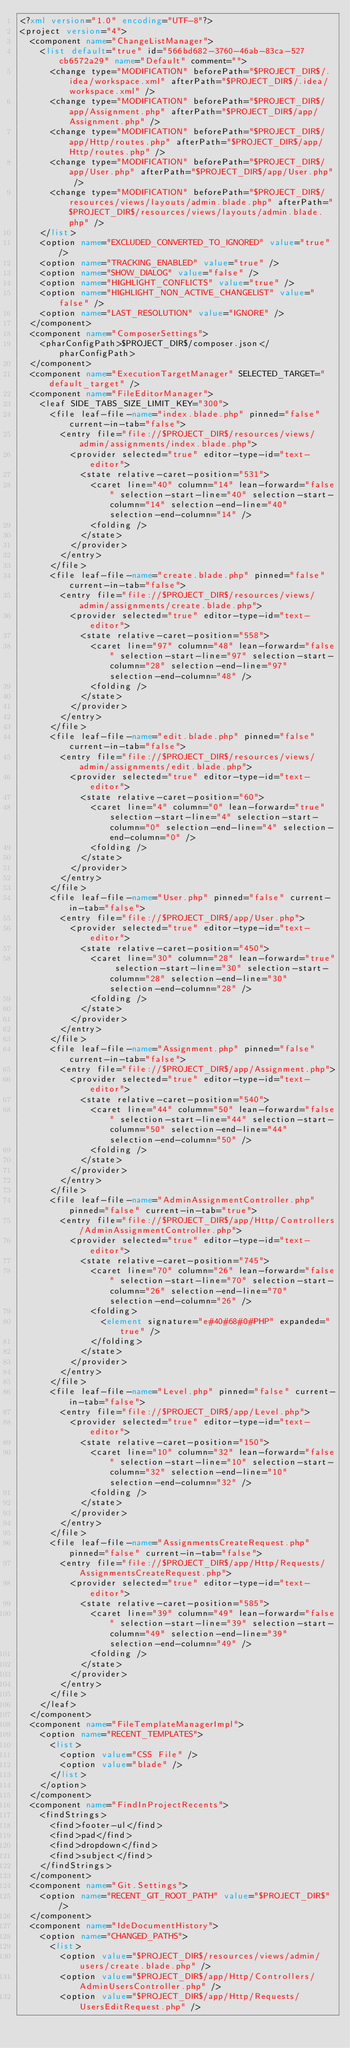Convert code to text. <code><loc_0><loc_0><loc_500><loc_500><_XML_><?xml version="1.0" encoding="UTF-8"?>
<project version="4">
  <component name="ChangeListManager">
    <list default="true" id="566bd682-3760-46ab-83ca-527cb6572a29" name="Default" comment="">
      <change type="MODIFICATION" beforePath="$PROJECT_DIR$/.idea/workspace.xml" afterPath="$PROJECT_DIR$/.idea/workspace.xml" />
      <change type="MODIFICATION" beforePath="$PROJECT_DIR$/app/Assignment.php" afterPath="$PROJECT_DIR$/app/Assignment.php" />
      <change type="MODIFICATION" beforePath="$PROJECT_DIR$/app/Http/routes.php" afterPath="$PROJECT_DIR$/app/Http/routes.php" />
      <change type="MODIFICATION" beforePath="$PROJECT_DIR$/app/User.php" afterPath="$PROJECT_DIR$/app/User.php" />
      <change type="MODIFICATION" beforePath="$PROJECT_DIR$/resources/views/layouts/admin.blade.php" afterPath="$PROJECT_DIR$/resources/views/layouts/admin.blade.php" />
    </list>
    <option name="EXCLUDED_CONVERTED_TO_IGNORED" value="true" />
    <option name="TRACKING_ENABLED" value="true" />
    <option name="SHOW_DIALOG" value="false" />
    <option name="HIGHLIGHT_CONFLICTS" value="true" />
    <option name="HIGHLIGHT_NON_ACTIVE_CHANGELIST" value="false" />
    <option name="LAST_RESOLUTION" value="IGNORE" />
  </component>
  <component name="ComposerSettings">
    <pharConfigPath>$PROJECT_DIR$/composer.json</pharConfigPath>
  </component>
  <component name="ExecutionTargetManager" SELECTED_TARGET="default_target" />
  <component name="FileEditorManager">
    <leaf SIDE_TABS_SIZE_LIMIT_KEY="300">
      <file leaf-file-name="index.blade.php" pinned="false" current-in-tab="false">
        <entry file="file://$PROJECT_DIR$/resources/views/admin/assignments/index.blade.php">
          <provider selected="true" editor-type-id="text-editor">
            <state relative-caret-position="531">
              <caret line="40" column="14" lean-forward="false" selection-start-line="40" selection-start-column="14" selection-end-line="40" selection-end-column="14" />
              <folding />
            </state>
          </provider>
        </entry>
      </file>
      <file leaf-file-name="create.blade.php" pinned="false" current-in-tab="false">
        <entry file="file://$PROJECT_DIR$/resources/views/admin/assignments/create.blade.php">
          <provider selected="true" editor-type-id="text-editor">
            <state relative-caret-position="558">
              <caret line="97" column="48" lean-forward="false" selection-start-line="97" selection-start-column="28" selection-end-line="97" selection-end-column="48" />
              <folding />
            </state>
          </provider>
        </entry>
      </file>
      <file leaf-file-name="edit.blade.php" pinned="false" current-in-tab="false">
        <entry file="file://$PROJECT_DIR$/resources/views/admin/assignments/edit.blade.php">
          <provider selected="true" editor-type-id="text-editor">
            <state relative-caret-position="60">
              <caret line="4" column="0" lean-forward="true" selection-start-line="4" selection-start-column="0" selection-end-line="4" selection-end-column="0" />
              <folding />
            </state>
          </provider>
        </entry>
      </file>
      <file leaf-file-name="User.php" pinned="false" current-in-tab="false">
        <entry file="file://$PROJECT_DIR$/app/User.php">
          <provider selected="true" editor-type-id="text-editor">
            <state relative-caret-position="450">
              <caret line="30" column="28" lean-forward="true" selection-start-line="30" selection-start-column="28" selection-end-line="30" selection-end-column="28" />
              <folding />
            </state>
          </provider>
        </entry>
      </file>
      <file leaf-file-name="Assignment.php" pinned="false" current-in-tab="false">
        <entry file="file://$PROJECT_DIR$/app/Assignment.php">
          <provider selected="true" editor-type-id="text-editor">
            <state relative-caret-position="540">
              <caret line="44" column="50" lean-forward="false" selection-start-line="44" selection-start-column="50" selection-end-line="44" selection-end-column="50" />
              <folding />
            </state>
          </provider>
        </entry>
      </file>
      <file leaf-file-name="AdminAssignmentController.php" pinned="false" current-in-tab="true">
        <entry file="file://$PROJECT_DIR$/app/Http/Controllers/AdminAssignmentController.php">
          <provider selected="true" editor-type-id="text-editor">
            <state relative-caret-position="745">
              <caret line="70" column="26" lean-forward="false" selection-start-line="70" selection-start-column="26" selection-end-line="70" selection-end-column="26" />
              <folding>
                <element signature="e#40#68#0#PHP" expanded="true" />
              </folding>
            </state>
          </provider>
        </entry>
      </file>
      <file leaf-file-name="Level.php" pinned="false" current-in-tab="false">
        <entry file="file://$PROJECT_DIR$/app/Level.php">
          <provider selected="true" editor-type-id="text-editor">
            <state relative-caret-position="150">
              <caret line="10" column="32" lean-forward="false" selection-start-line="10" selection-start-column="32" selection-end-line="10" selection-end-column="32" />
              <folding />
            </state>
          </provider>
        </entry>
      </file>
      <file leaf-file-name="AssignmentsCreateRequest.php" pinned="false" current-in-tab="false">
        <entry file="file://$PROJECT_DIR$/app/Http/Requests/AssignmentsCreateRequest.php">
          <provider selected="true" editor-type-id="text-editor">
            <state relative-caret-position="585">
              <caret line="39" column="49" lean-forward="false" selection-start-line="39" selection-start-column="49" selection-end-line="39" selection-end-column="49" />
              <folding />
            </state>
          </provider>
        </entry>
      </file>
    </leaf>
  </component>
  <component name="FileTemplateManagerImpl">
    <option name="RECENT_TEMPLATES">
      <list>
        <option value="CSS File" />
        <option value="blade" />
      </list>
    </option>
  </component>
  <component name="FindInProjectRecents">
    <findStrings>
      <find>footer-ul</find>
      <find>pad</find>
      <find>dropdown</find>
      <find>subject</find>
    </findStrings>
  </component>
  <component name="Git.Settings">
    <option name="RECENT_GIT_ROOT_PATH" value="$PROJECT_DIR$" />
  </component>
  <component name="IdeDocumentHistory">
    <option name="CHANGED_PATHS">
      <list>
        <option value="$PROJECT_DIR$/resources/views/admin/users/create.blade.php" />
        <option value="$PROJECT_DIR$/app/Http/Controllers/AdminUsersController.php" />
        <option value="$PROJECT_DIR$/app/Http/Requests/UsersEditRequest.php" /></code> 